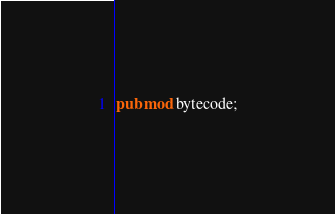<code> <loc_0><loc_0><loc_500><loc_500><_Rust_>pub mod bytecode;
</code> 